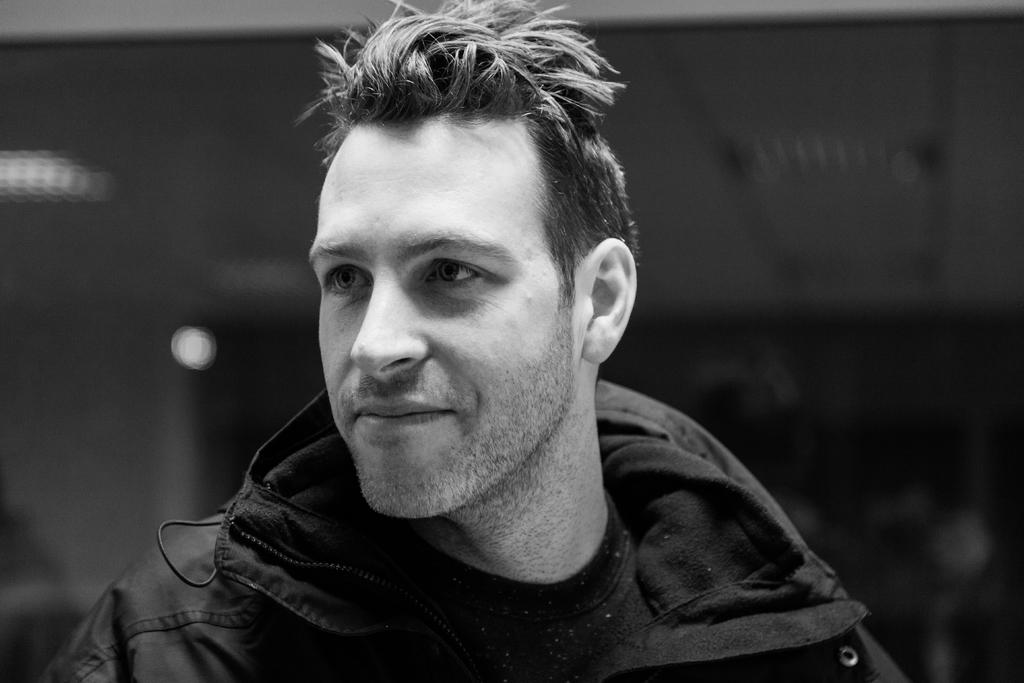What is the main subject in the foreground of the image? There is a man in the foreground of the image. What is the color scheme of the image? The image is in black and white. Can you describe the background of the image? The background of the image is blurry. What type of plantation can be seen in the background of the image? There is no plantation present in the image; the background is blurry. 